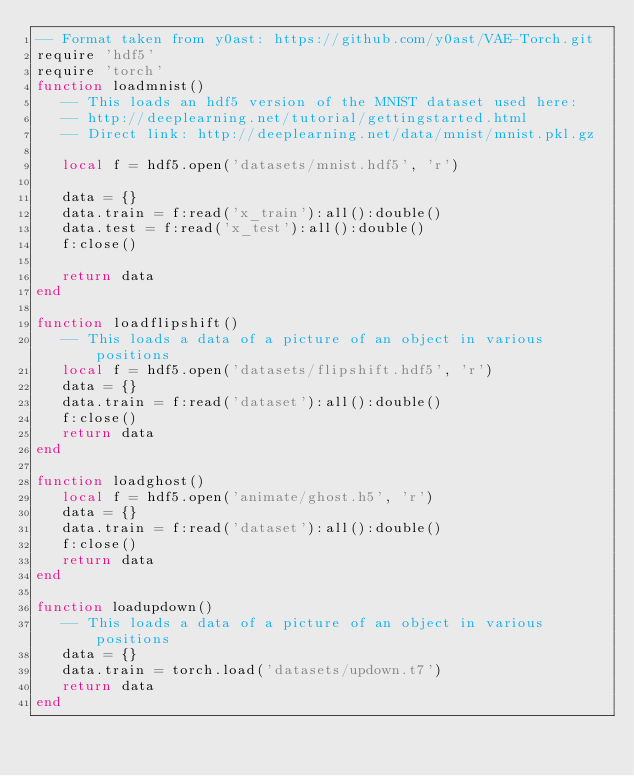Convert code to text. <code><loc_0><loc_0><loc_500><loc_500><_Lua_>-- Format taken from y0ast: https://github.com/y0ast/VAE-Torch.git
require 'hdf5'
require 'torch'
function loadmnist()
   -- This loads an hdf5 version of the MNIST dataset used here:
   -- http://deeplearning.net/tutorial/gettingstarted.html
   -- Direct link: http://deeplearning.net/data/mnist/mnist.pkl.gz

   local f = hdf5.open('datasets/mnist.hdf5', 'r')

   data = {}
   data.train = f:read('x_train'):all():double()
   data.test = f:read('x_test'):all():double()
   f:close()

   return data
end

function loadflipshift()
   -- This loads a data of a picture of an object in various positions
   local f = hdf5.open('datasets/flipshift.hdf5', 'r')
   data = {}
   data.train = f:read('dataset'):all():double()
   f:close()
   return data
end

function loadghost()
   local f = hdf5.open('animate/ghost.h5', 'r')
   data = {}
   data.train = f:read('dataset'):all():double()
   f:close()
   return data
end

function loadupdown()
   -- This loads a data of a picture of an object in various positions
   data = {}
   data.train = torch.load('datasets/updown.t7')
   return data
end

</code> 